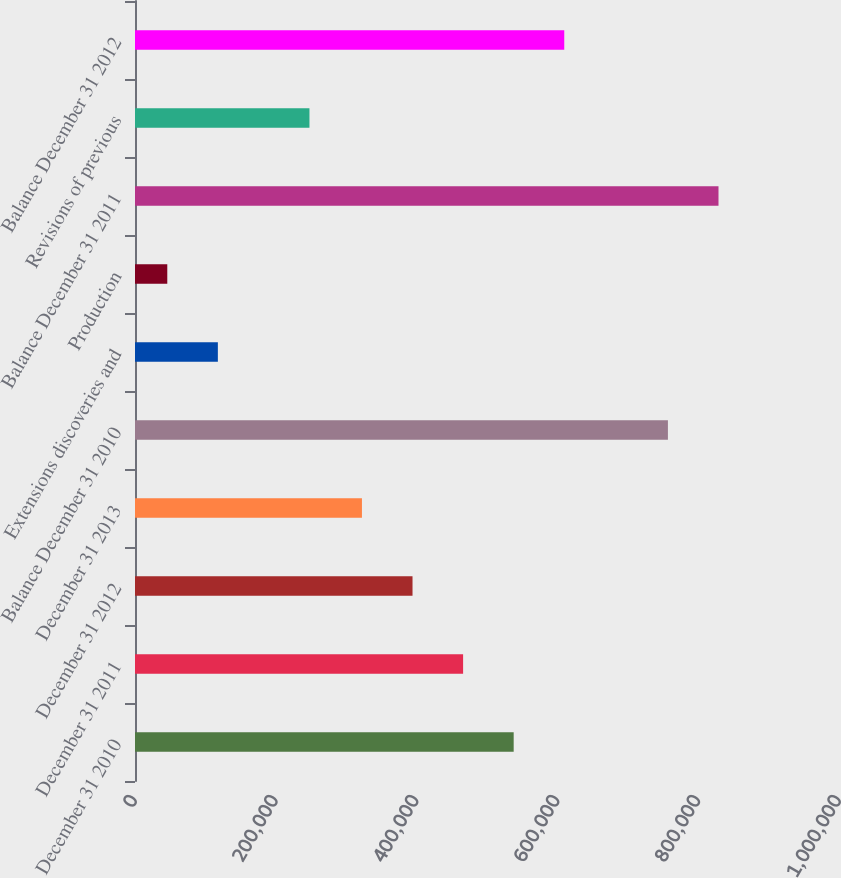Convert chart to OTSL. <chart><loc_0><loc_0><loc_500><loc_500><bar_chart><fcel>December 31 2010<fcel>December 31 2011<fcel>December 31 2012<fcel>December 31 2013<fcel>Balance December 31 2010<fcel>Extensions discoveries and<fcel>Production<fcel>Balance December 31 2011<fcel>Revisions of previous<fcel>Balance December 31 2012<nl><fcel>537893<fcel>466049<fcel>394206<fcel>322362<fcel>756984<fcel>117700<fcel>45856<fcel>828828<fcel>247811<fcel>609737<nl></chart> 